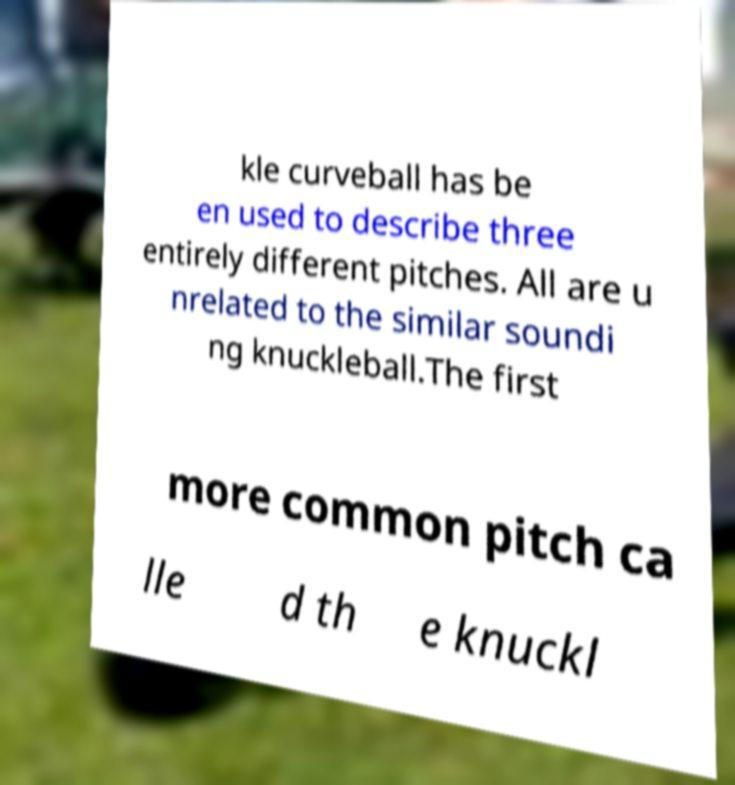Can you read and provide the text displayed in the image?This photo seems to have some interesting text. Can you extract and type it out for me? kle curveball has be en used to describe three entirely different pitches. All are u nrelated to the similar soundi ng knuckleball.The first more common pitch ca lle d th e knuckl 